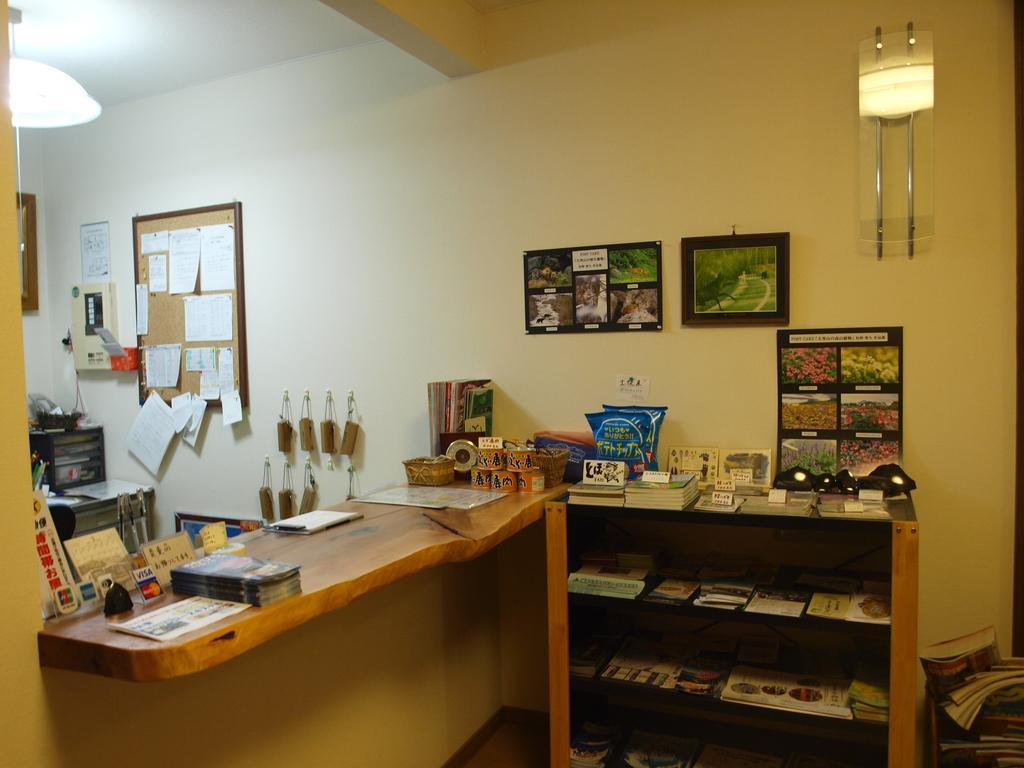Could you give a brief overview of what you see in this image? In this image I see a desk and on the desk I see few books and few boxes over here, On the right I see a rack and lots of books in it. I see few pictures of nature on the wall and on the rack, on the right I see a notice board on which there are few papers on it and on the top I see the light. 